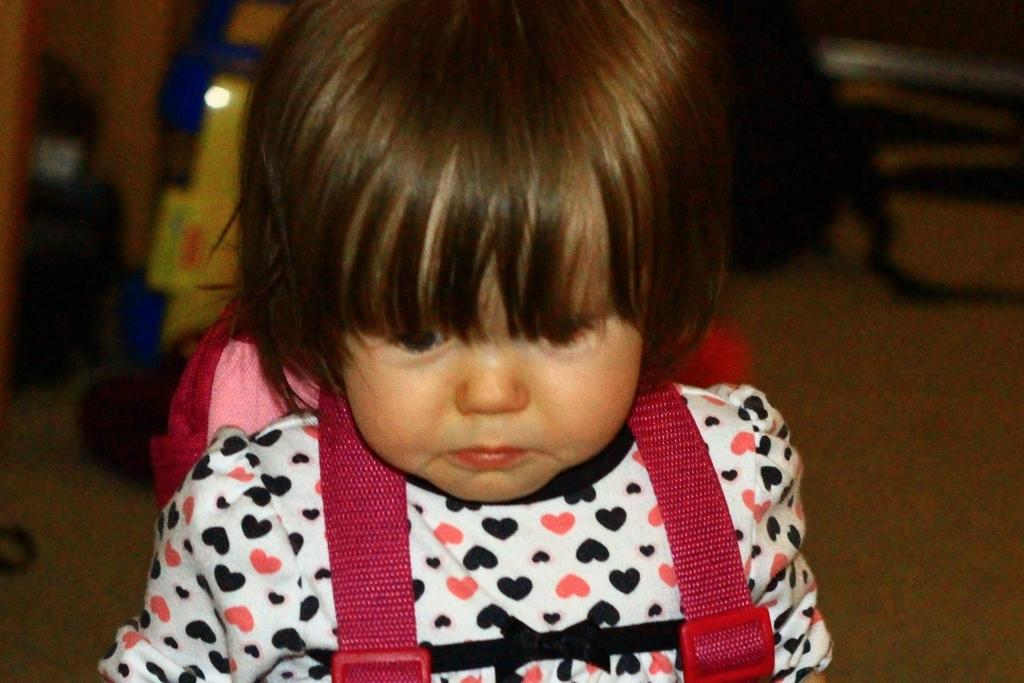What is the main subject of the image? The main subject of the image is a kid. What is the kid holding in the image? The kid is holding a backpack. What type of boundary can be seen in the image? There is no boundary present in the image. What sound can be heard coming from the backpack in the image? There is no sound coming from the backpack in the image, as it is an inanimate object. 